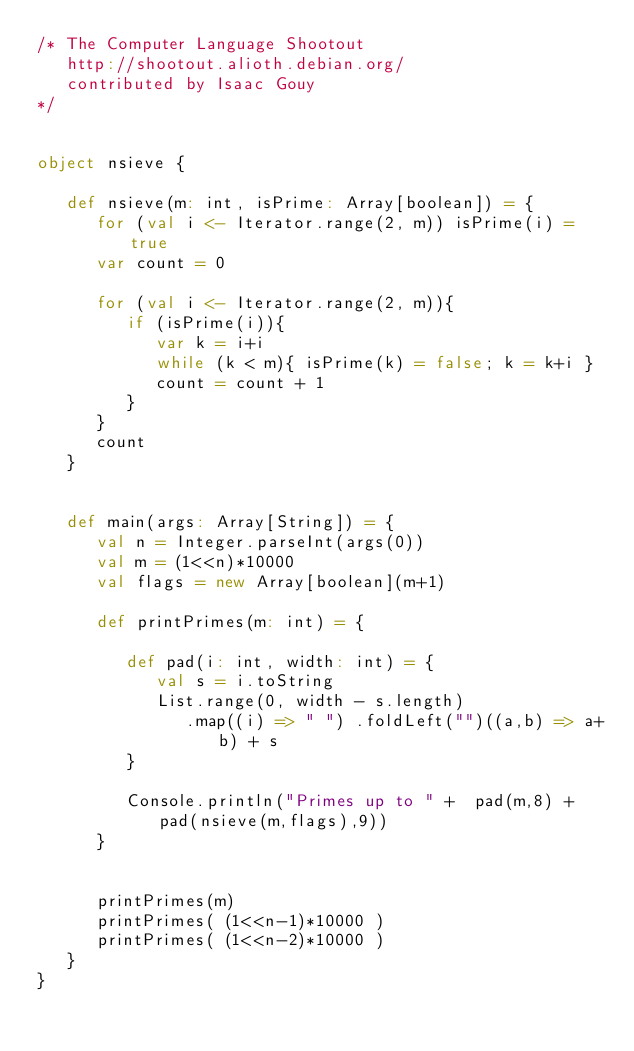<code> <loc_0><loc_0><loc_500><loc_500><_Scala_>/* The Computer Language Shootout
   http://shootout.alioth.debian.org/
   contributed by Isaac Gouy
*/


object nsieve { 

   def nsieve(m: int, isPrime: Array[boolean]) = {
      for (val i <- Iterator.range(2, m)) isPrime(i) = true
      var count = 0

      for (val i <- Iterator.range(2, m)){
         if (isPrime(i)){
            var k = i+i
            while (k < m){ isPrime(k) = false; k = k+i }
            count = count + 1
         }
      }
      count
   }


   def main(args: Array[String]) = {
      val n = Integer.parseInt(args(0))
      val m = (1<<n)*10000
      val flags = new Array[boolean](m+1)

      def printPrimes(m: int) = {

         def pad(i: int, width: int) = {
            val s = i.toString
            List.range(0, width - s.length)
               .map((i) => " ") .foldLeft("")((a,b) => a+b) + s 
         }

         Console.println("Primes up to " +  pad(m,8) + pad(nsieve(m,flags),9))
      }


      printPrimes(m)
      printPrimes( (1<<n-1)*10000 )
      printPrimes( (1<<n-2)*10000 )
   } 
}
</code> 